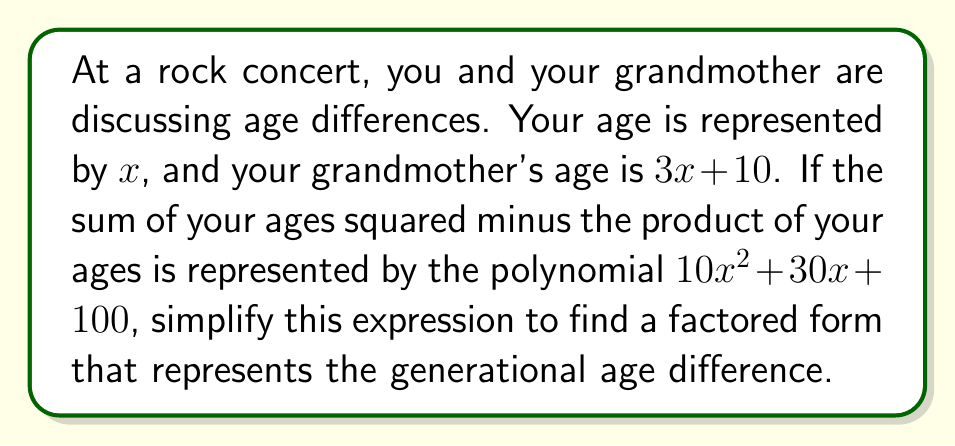Help me with this question. Let's approach this step-by-step:

1) Your age: $x$
   Grandmother's age: $3x + 10$

2) The given polynomial: $10x^2 + 30x + 100$

3) This polynomial represents: $(x + (3x+10))^2 - x(3x+10)$

4) Let's expand this:
   $$(x + 3x + 10)^2 - (3x^2 + 10x)$$
   $$(4x + 10)^2 - 3x^2 - 10x$$

5) Expand $(4x + 10)^2$:
   $$16x^2 + 80x + 100 - 3x^2 - 10x$$

6) Simplify:
   $$13x^2 + 70x + 100$$

7) This matches our given polynomial $10x^2 + 30x + 100$, so our setup is correct.

8) To factor this, let's look for a common factor:
   $$10x^2 + 30x + 100 = 10(x^2 + 3x + 10)$$

9) The expression inside the parentheses is a quadratic. Let's check if it can be factored:
   $b^2 - 4ac = 3^2 - 4(1)(10) = 9 - 40 = -31$
   
   Since this is negative, the quadratic cannot be factored further.

10) Therefore, our final factored form is:
    $$10(x^2 + 3x + 10)$$

This expression represents the generational age difference, where $x$ is your age and $3x + 10$ is your grandmother's age.
Answer: $10(x^2 + 3x + 10)$ 